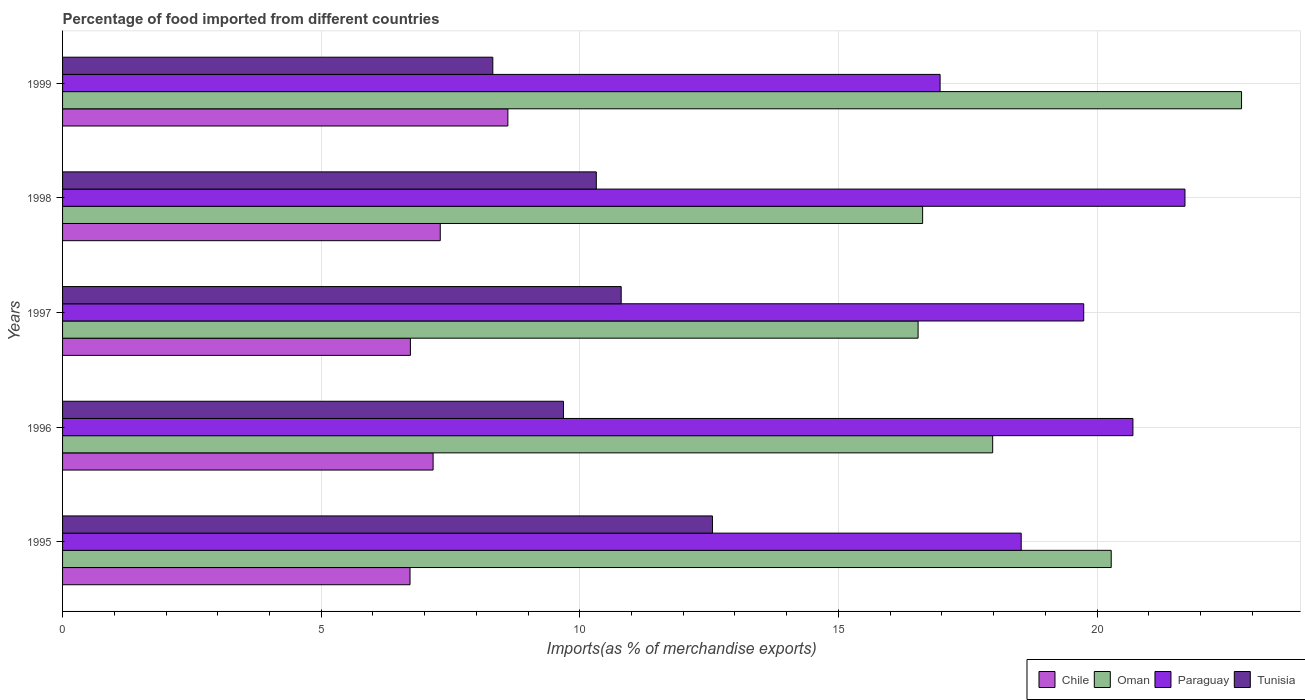How many different coloured bars are there?
Offer a terse response. 4. Are the number of bars on each tick of the Y-axis equal?
Give a very brief answer. Yes. How many bars are there on the 3rd tick from the top?
Keep it short and to the point. 4. What is the percentage of imports to different countries in Tunisia in 1996?
Keep it short and to the point. 9.68. Across all years, what is the maximum percentage of imports to different countries in Paraguay?
Your answer should be compact. 21.7. Across all years, what is the minimum percentage of imports to different countries in Paraguay?
Keep it short and to the point. 16.97. In which year was the percentage of imports to different countries in Chile maximum?
Make the answer very short. 1999. In which year was the percentage of imports to different countries in Paraguay minimum?
Your response must be concise. 1999. What is the total percentage of imports to different countries in Tunisia in the graph?
Provide a short and direct response. 51.69. What is the difference between the percentage of imports to different countries in Tunisia in 1995 and that in 1999?
Your answer should be compact. 4.25. What is the difference between the percentage of imports to different countries in Tunisia in 1996 and the percentage of imports to different countries in Chile in 1999?
Your answer should be very brief. 1.07. What is the average percentage of imports to different countries in Chile per year?
Provide a succinct answer. 7.3. In the year 1998, what is the difference between the percentage of imports to different countries in Chile and percentage of imports to different countries in Oman?
Offer a very short reply. -9.33. In how many years, is the percentage of imports to different countries in Oman greater than 21 %?
Provide a succinct answer. 1. What is the ratio of the percentage of imports to different countries in Oman in 1995 to that in 1999?
Your answer should be compact. 0.89. Is the percentage of imports to different countries in Oman in 1995 less than that in 1998?
Offer a terse response. No. What is the difference between the highest and the second highest percentage of imports to different countries in Oman?
Your answer should be compact. 2.52. What is the difference between the highest and the lowest percentage of imports to different countries in Paraguay?
Provide a short and direct response. 4.73. In how many years, is the percentage of imports to different countries in Paraguay greater than the average percentage of imports to different countries in Paraguay taken over all years?
Keep it short and to the point. 3. Is the sum of the percentage of imports to different countries in Tunisia in 1996 and 1998 greater than the maximum percentage of imports to different countries in Paraguay across all years?
Provide a succinct answer. No. What does the 4th bar from the top in 1999 represents?
Your response must be concise. Chile. What does the 3rd bar from the bottom in 1998 represents?
Your response must be concise. Paraguay. Is it the case that in every year, the sum of the percentage of imports to different countries in Paraguay and percentage of imports to different countries in Chile is greater than the percentage of imports to different countries in Oman?
Provide a short and direct response. Yes. How many years are there in the graph?
Keep it short and to the point. 5. What is the difference between two consecutive major ticks on the X-axis?
Ensure brevity in your answer.  5. Are the values on the major ticks of X-axis written in scientific E-notation?
Ensure brevity in your answer.  No. Does the graph contain grids?
Your answer should be compact. Yes. How many legend labels are there?
Give a very brief answer. 4. What is the title of the graph?
Your response must be concise. Percentage of food imported from different countries. Does "Belgium" appear as one of the legend labels in the graph?
Offer a very short reply. No. What is the label or title of the X-axis?
Your answer should be compact. Imports(as % of merchandise exports). What is the label or title of the Y-axis?
Ensure brevity in your answer.  Years. What is the Imports(as % of merchandise exports) of Chile in 1995?
Offer a very short reply. 6.72. What is the Imports(as % of merchandise exports) of Oman in 1995?
Your response must be concise. 20.27. What is the Imports(as % of merchandise exports) of Paraguay in 1995?
Ensure brevity in your answer.  18.53. What is the Imports(as % of merchandise exports) in Tunisia in 1995?
Your response must be concise. 12.57. What is the Imports(as % of merchandise exports) in Chile in 1996?
Make the answer very short. 7.16. What is the Imports(as % of merchandise exports) in Oman in 1996?
Give a very brief answer. 17.98. What is the Imports(as % of merchandise exports) of Paraguay in 1996?
Make the answer very short. 20.69. What is the Imports(as % of merchandise exports) in Tunisia in 1996?
Provide a short and direct response. 9.68. What is the Imports(as % of merchandise exports) in Chile in 1997?
Offer a very short reply. 6.73. What is the Imports(as % of merchandise exports) of Oman in 1997?
Your answer should be compact. 16.54. What is the Imports(as % of merchandise exports) in Paraguay in 1997?
Ensure brevity in your answer.  19.74. What is the Imports(as % of merchandise exports) of Tunisia in 1997?
Provide a short and direct response. 10.8. What is the Imports(as % of merchandise exports) in Chile in 1998?
Provide a succinct answer. 7.3. What is the Imports(as % of merchandise exports) in Oman in 1998?
Provide a succinct answer. 16.63. What is the Imports(as % of merchandise exports) in Paraguay in 1998?
Your response must be concise. 21.7. What is the Imports(as % of merchandise exports) in Tunisia in 1998?
Ensure brevity in your answer.  10.32. What is the Imports(as % of merchandise exports) of Chile in 1999?
Your answer should be very brief. 8.61. What is the Imports(as % of merchandise exports) of Oman in 1999?
Your answer should be very brief. 22.79. What is the Imports(as % of merchandise exports) of Paraguay in 1999?
Offer a terse response. 16.97. What is the Imports(as % of merchandise exports) in Tunisia in 1999?
Ensure brevity in your answer.  8.32. Across all years, what is the maximum Imports(as % of merchandise exports) in Chile?
Give a very brief answer. 8.61. Across all years, what is the maximum Imports(as % of merchandise exports) in Oman?
Offer a terse response. 22.79. Across all years, what is the maximum Imports(as % of merchandise exports) of Paraguay?
Offer a terse response. 21.7. Across all years, what is the maximum Imports(as % of merchandise exports) of Tunisia?
Your answer should be very brief. 12.57. Across all years, what is the minimum Imports(as % of merchandise exports) of Chile?
Provide a succinct answer. 6.72. Across all years, what is the minimum Imports(as % of merchandise exports) of Oman?
Ensure brevity in your answer.  16.54. Across all years, what is the minimum Imports(as % of merchandise exports) of Paraguay?
Ensure brevity in your answer.  16.97. Across all years, what is the minimum Imports(as % of merchandise exports) in Tunisia?
Ensure brevity in your answer.  8.32. What is the total Imports(as % of merchandise exports) in Chile in the graph?
Make the answer very short. 36.52. What is the total Imports(as % of merchandise exports) in Oman in the graph?
Provide a short and direct response. 94.22. What is the total Imports(as % of merchandise exports) in Paraguay in the graph?
Make the answer very short. 97.64. What is the total Imports(as % of merchandise exports) of Tunisia in the graph?
Provide a succinct answer. 51.69. What is the difference between the Imports(as % of merchandise exports) of Chile in 1995 and that in 1996?
Offer a terse response. -0.45. What is the difference between the Imports(as % of merchandise exports) of Oman in 1995 and that in 1996?
Provide a short and direct response. 2.29. What is the difference between the Imports(as % of merchandise exports) of Paraguay in 1995 and that in 1996?
Make the answer very short. -2.16. What is the difference between the Imports(as % of merchandise exports) of Tunisia in 1995 and that in 1996?
Offer a terse response. 2.88. What is the difference between the Imports(as % of merchandise exports) in Chile in 1995 and that in 1997?
Ensure brevity in your answer.  -0.01. What is the difference between the Imports(as % of merchandise exports) in Oman in 1995 and that in 1997?
Provide a succinct answer. 3.73. What is the difference between the Imports(as % of merchandise exports) in Paraguay in 1995 and that in 1997?
Offer a terse response. -1.21. What is the difference between the Imports(as % of merchandise exports) in Tunisia in 1995 and that in 1997?
Offer a terse response. 1.76. What is the difference between the Imports(as % of merchandise exports) of Chile in 1995 and that in 1998?
Provide a succinct answer. -0.58. What is the difference between the Imports(as % of merchandise exports) in Oman in 1995 and that in 1998?
Your answer should be very brief. 3.65. What is the difference between the Imports(as % of merchandise exports) in Paraguay in 1995 and that in 1998?
Your answer should be very brief. -3.17. What is the difference between the Imports(as % of merchandise exports) of Tunisia in 1995 and that in 1998?
Make the answer very short. 2.25. What is the difference between the Imports(as % of merchandise exports) of Chile in 1995 and that in 1999?
Keep it short and to the point. -1.89. What is the difference between the Imports(as % of merchandise exports) of Oman in 1995 and that in 1999?
Your answer should be compact. -2.52. What is the difference between the Imports(as % of merchandise exports) of Paraguay in 1995 and that in 1999?
Keep it short and to the point. 1.57. What is the difference between the Imports(as % of merchandise exports) of Tunisia in 1995 and that in 1999?
Your answer should be compact. 4.25. What is the difference between the Imports(as % of merchandise exports) in Chile in 1996 and that in 1997?
Give a very brief answer. 0.44. What is the difference between the Imports(as % of merchandise exports) of Oman in 1996 and that in 1997?
Make the answer very short. 1.44. What is the difference between the Imports(as % of merchandise exports) in Paraguay in 1996 and that in 1997?
Offer a terse response. 0.95. What is the difference between the Imports(as % of merchandise exports) in Tunisia in 1996 and that in 1997?
Give a very brief answer. -1.12. What is the difference between the Imports(as % of merchandise exports) of Chile in 1996 and that in 1998?
Your answer should be very brief. -0.14. What is the difference between the Imports(as % of merchandise exports) in Oman in 1996 and that in 1998?
Give a very brief answer. 1.35. What is the difference between the Imports(as % of merchandise exports) in Paraguay in 1996 and that in 1998?
Provide a short and direct response. -1.01. What is the difference between the Imports(as % of merchandise exports) in Tunisia in 1996 and that in 1998?
Offer a very short reply. -0.64. What is the difference between the Imports(as % of merchandise exports) of Chile in 1996 and that in 1999?
Offer a very short reply. -1.45. What is the difference between the Imports(as % of merchandise exports) of Oman in 1996 and that in 1999?
Your answer should be very brief. -4.81. What is the difference between the Imports(as % of merchandise exports) in Paraguay in 1996 and that in 1999?
Your answer should be compact. 3.73. What is the difference between the Imports(as % of merchandise exports) in Tunisia in 1996 and that in 1999?
Your response must be concise. 1.37. What is the difference between the Imports(as % of merchandise exports) of Chile in 1997 and that in 1998?
Ensure brevity in your answer.  -0.58. What is the difference between the Imports(as % of merchandise exports) in Oman in 1997 and that in 1998?
Your answer should be compact. -0.09. What is the difference between the Imports(as % of merchandise exports) of Paraguay in 1997 and that in 1998?
Offer a very short reply. -1.96. What is the difference between the Imports(as % of merchandise exports) in Tunisia in 1997 and that in 1998?
Ensure brevity in your answer.  0.48. What is the difference between the Imports(as % of merchandise exports) in Chile in 1997 and that in 1999?
Offer a terse response. -1.88. What is the difference between the Imports(as % of merchandise exports) in Oman in 1997 and that in 1999?
Your response must be concise. -6.25. What is the difference between the Imports(as % of merchandise exports) in Paraguay in 1997 and that in 1999?
Ensure brevity in your answer.  2.78. What is the difference between the Imports(as % of merchandise exports) of Tunisia in 1997 and that in 1999?
Ensure brevity in your answer.  2.48. What is the difference between the Imports(as % of merchandise exports) of Chile in 1998 and that in 1999?
Your answer should be very brief. -1.31. What is the difference between the Imports(as % of merchandise exports) of Oman in 1998 and that in 1999?
Your answer should be compact. -6.17. What is the difference between the Imports(as % of merchandise exports) in Paraguay in 1998 and that in 1999?
Keep it short and to the point. 4.73. What is the difference between the Imports(as % of merchandise exports) in Tunisia in 1998 and that in 1999?
Keep it short and to the point. 2. What is the difference between the Imports(as % of merchandise exports) of Chile in 1995 and the Imports(as % of merchandise exports) of Oman in 1996?
Offer a very short reply. -11.26. What is the difference between the Imports(as % of merchandise exports) of Chile in 1995 and the Imports(as % of merchandise exports) of Paraguay in 1996?
Offer a terse response. -13.98. What is the difference between the Imports(as % of merchandise exports) in Chile in 1995 and the Imports(as % of merchandise exports) in Tunisia in 1996?
Your response must be concise. -2.97. What is the difference between the Imports(as % of merchandise exports) in Oman in 1995 and the Imports(as % of merchandise exports) in Paraguay in 1996?
Your answer should be very brief. -0.42. What is the difference between the Imports(as % of merchandise exports) of Oman in 1995 and the Imports(as % of merchandise exports) of Tunisia in 1996?
Make the answer very short. 10.59. What is the difference between the Imports(as % of merchandise exports) in Paraguay in 1995 and the Imports(as % of merchandise exports) in Tunisia in 1996?
Give a very brief answer. 8.85. What is the difference between the Imports(as % of merchandise exports) of Chile in 1995 and the Imports(as % of merchandise exports) of Oman in 1997?
Make the answer very short. -9.82. What is the difference between the Imports(as % of merchandise exports) of Chile in 1995 and the Imports(as % of merchandise exports) of Paraguay in 1997?
Provide a succinct answer. -13.02. What is the difference between the Imports(as % of merchandise exports) in Chile in 1995 and the Imports(as % of merchandise exports) in Tunisia in 1997?
Your response must be concise. -4.08. What is the difference between the Imports(as % of merchandise exports) in Oman in 1995 and the Imports(as % of merchandise exports) in Paraguay in 1997?
Your answer should be very brief. 0.53. What is the difference between the Imports(as % of merchandise exports) of Oman in 1995 and the Imports(as % of merchandise exports) of Tunisia in 1997?
Your response must be concise. 9.47. What is the difference between the Imports(as % of merchandise exports) in Paraguay in 1995 and the Imports(as % of merchandise exports) in Tunisia in 1997?
Provide a short and direct response. 7.73. What is the difference between the Imports(as % of merchandise exports) of Chile in 1995 and the Imports(as % of merchandise exports) of Oman in 1998?
Ensure brevity in your answer.  -9.91. What is the difference between the Imports(as % of merchandise exports) of Chile in 1995 and the Imports(as % of merchandise exports) of Paraguay in 1998?
Make the answer very short. -14.98. What is the difference between the Imports(as % of merchandise exports) in Chile in 1995 and the Imports(as % of merchandise exports) in Tunisia in 1998?
Ensure brevity in your answer.  -3.6. What is the difference between the Imports(as % of merchandise exports) of Oman in 1995 and the Imports(as % of merchandise exports) of Paraguay in 1998?
Provide a succinct answer. -1.43. What is the difference between the Imports(as % of merchandise exports) in Oman in 1995 and the Imports(as % of merchandise exports) in Tunisia in 1998?
Give a very brief answer. 9.95. What is the difference between the Imports(as % of merchandise exports) of Paraguay in 1995 and the Imports(as % of merchandise exports) of Tunisia in 1998?
Provide a short and direct response. 8.21. What is the difference between the Imports(as % of merchandise exports) in Chile in 1995 and the Imports(as % of merchandise exports) in Oman in 1999?
Offer a very short reply. -16.08. What is the difference between the Imports(as % of merchandise exports) of Chile in 1995 and the Imports(as % of merchandise exports) of Paraguay in 1999?
Give a very brief answer. -10.25. What is the difference between the Imports(as % of merchandise exports) of Chile in 1995 and the Imports(as % of merchandise exports) of Tunisia in 1999?
Offer a very short reply. -1.6. What is the difference between the Imports(as % of merchandise exports) of Oman in 1995 and the Imports(as % of merchandise exports) of Paraguay in 1999?
Provide a short and direct response. 3.31. What is the difference between the Imports(as % of merchandise exports) of Oman in 1995 and the Imports(as % of merchandise exports) of Tunisia in 1999?
Your answer should be compact. 11.96. What is the difference between the Imports(as % of merchandise exports) in Paraguay in 1995 and the Imports(as % of merchandise exports) in Tunisia in 1999?
Offer a terse response. 10.22. What is the difference between the Imports(as % of merchandise exports) in Chile in 1996 and the Imports(as % of merchandise exports) in Oman in 1997?
Offer a very short reply. -9.38. What is the difference between the Imports(as % of merchandise exports) in Chile in 1996 and the Imports(as % of merchandise exports) in Paraguay in 1997?
Provide a succinct answer. -12.58. What is the difference between the Imports(as % of merchandise exports) in Chile in 1996 and the Imports(as % of merchandise exports) in Tunisia in 1997?
Your answer should be very brief. -3.64. What is the difference between the Imports(as % of merchandise exports) of Oman in 1996 and the Imports(as % of merchandise exports) of Paraguay in 1997?
Provide a succinct answer. -1.76. What is the difference between the Imports(as % of merchandise exports) in Oman in 1996 and the Imports(as % of merchandise exports) in Tunisia in 1997?
Your answer should be very brief. 7.18. What is the difference between the Imports(as % of merchandise exports) in Paraguay in 1996 and the Imports(as % of merchandise exports) in Tunisia in 1997?
Provide a short and direct response. 9.89. What is the difference between the Imports(as % of merchandise exports) in Chile in 1996 and the Imports(as % of merchandise exports) in Oman in 1998?
Provide a succinct answer. -9.46. What is the difference between the Imports(as % of merchandise exports) of Chile in 1996 and the Imports(as % of merchandise exports) of Paraguay in 1998?
Ensure brevity in your answer.  -14.54. What is the difference between the Imports(as % of merchandise exports) in Chile in 1996 and the Imports(as % of merchandise exports) in Tunisia in 1998?
Give a very brief answer. -3.16. What is the difference between the Imports(as % of merchandise exports) of Oman in 1996 and the Imports(as % of merchandise exports) of Paraguay in 1998?
Provide a short and direct response. -3.72. What is the difference between the Imports(as % of merchandise exports) in Oman in 1996 and the Imports(as % of merchandise exports) in Tunisia in 1998?
Keep it short and to the point. 7.66. What is the difference between the Imports(as % of merchandise exports) in Paraguay in 1996 and the Imports(as % of merchandise exports) in Tunisia in 1998?
Your answer should be compact. 10.37. What is the difference between the Imports(as % of merchandise exports) of Chile in 1996 and the Imports(as % of merchandise exports) of Oman in 1999?
Give a very brief answer. -15.63. What is the difference between the Imports(as % of merchandise exports) in Chile in 1996 and the Imports(as % of merchandise exports) in Paraguay in 1999?
Make the answer very short. -9.8. What is the difference between the Imports(as % of merchandise exports) of Chile in 1996 and the Imports(as % of merchandise exports) of Tunisia in 1999?
Provide a succinct answer. -1.15. What is the difference between the Imports(as % of merchandise exports) of Oman in 1996 and the Imports(as % of merchandise exports) of Paraguay in 1999?
Provide a short and direct response. 1.02. What is the difference between the Imports(as % of merchandise exports) in Oman in 1996 and the Imports(as % of merchandise exports) in Tunisia in 1999?
Your response must be concise. 9.66. What is the difference between the Imports(as % of merchandise exports) of Paraguay in 1996 and the Imports(as % of merchandise exports) of Tunisia in 1999?
Keep it short and to the point. 12.38. What is the difference between the Imports(as % of merchandise exports) in Chile in 1997 and the Imports(as % of merchandise exports) in Oman in 1998?
Your answer should be compact. -9.9. What is the difference between the Imports(as % of merchandise exports) in Chile in 1997 and the Imports(as % of merchandise exports) in Paraguay in 1998?
Your answer should be compact. -14.98. What is the difference between the Imports(as % of merchandise exports) in Chile in 1997 and the Imports(as % of merchandise exports) in Tunisia in 1998?
Provide a succinct answer. -3.59. What is the difference between the Imports(as % of merchandise exports) of Oman in 1997 and the Imports(as % of merchandise exports) of Paraguay in 1998?
Give a very brief answer. -5.16. What is the difference between the Imports(as % of merchandise exports) in Oman in 1997 and the Imports(as % of merchandise exports) in Tunisia in 1998?
Ensure brevity in your answer.  6.22. What is the difference between the Imports(as % of merchandise exports) of Paraguay in 1997 and the Imports(as % of merchandise exports) of Tunisia in 1998?
Your response must be concise. 9.42. What is the difference between the Imports(as % of merchandise exports) of Chile in 1997 and the Imports(as % of merchandise exports) of Oman in 1999?
Your answer should be compact. -16.07. What is the difference between the Imports(as % of merchandise exports) in Chile in 1997 and the Imports(as % of merchandise exports) in Paraguay in 1999?
Give a very brief answer. -10.24. What is the difference between the Imports(as % of merchandise exports) of Chile in 1997 and the Imports(as % of merchandise exports) of Tunisia in 1999?
Make the answer very short. -1.59. What is the difference between the Imports(as % of merchandise exports) in Oman in 1997 and the Imports(as % of merchandise exports) in Paraguay in 1999?
Offer a terse response. -0.43. What is the difference between the Imports(as % of merchandise exports) in Oman in 1997 and the Imports(as % of merchandise exports) in Tunisia in 1999?
Make the answer very short. 8.22. What is the difference between the Imports(as % of merchandise exports) in Paraguay in 1997 and the Imports(as % of merchandise exports) in Tunisia in 1999?
Your answer should be compact. 11.42. What is the difference between the Imports(as % of merchandise exports) in Chile in 1998 and the Imports(as % of merchandise exports) in Oman in 1999?
Your response must be concise. -15.49. What is the difference between the Imports(as % of merchandise exports) of Chile in 1998 and the Imports(as % of merchandise exports) of Paraguay in 1999?
Offer a terse response. -9.66. What is the difference between the Imports(as % of merchandise exports) in Chile in 1998 and the Imports(as % of merchandise exports) in Tunisia in 1999?
Provide a succinct answer. -1.02. What is the difference between the Imports(as % of merchandise exports) in Oman in 1998 and the Imports(as % of merchandise exports) in Paraguay in 1999?
Keep it short and to the point. -0.34. What is the difference between the Imports(as % of merchandise exports) of Oman in 1998 and the Imports(as % of merchandise exports) of Tunisia in 1999?
Make the answer very short. 8.31. What is the difference between the Imports(as % of merchandise exports) of Paraguay in 1998 and the Imports(as % of merchandise exports) of Tunisia in 1999?
Your answer should be compact. 13.38. What is the average Imports(as % of merchandise exports) in Chile per year?
Your answer should be very brief. 7.3. What is the average Imports(as % of merchandise exports) of Oman per year?
Provide a short and direct response. 18.84. What is the average Imports(as % of merchandise exports) in Paraguay per year?
Provide a succinct answer. 19.53. What is the average Imports(as % of merchandise exports) of Tunisia per year?
Offer a terse response. 10.34. In the year 1995, what is the difference between the Imports(as % of merchandise exports) of Chile and Imports(as % of merchandise exports) of Oman?
Provide a short and direct response. -13.56. In the year 1995, what is the difference between the Imports(as % of merchandise exports) of Chile and Imports(as % of merchandise exports) of Paraguay?
Offer a very short reply. -11.82. In the year 1995, what is the difference between the Imports(as % of merchandise exports) of Chile and Imports(as % of merchandise exports) of Tunisia?
Provide a short and direct response. -5.85. In the year 1995, what is the difference between the Imports(as % of merchandise exports) in Oman and Imports(as % of merchandise exports) in Paraguay?
Keep it short and to the point. 1.74. In the year 1995, what is the difference between the Imports(as % of merchandise exports) of Oman and Imports(as % of merchandise exports) of Tunisia?
Provide a short and direct response. 7.71. In the year 1995, what is the difference between the Imports(as % of merchandise exports) in Paraguay and Imports(as % of merchandise exports) in Tunisia?
Provide a short and direct response. 5.97. In the year 1996, what is the difference between the Imports(as % of merchandise exports) in Chile and Imports(as % of merchandise exports) in Oman?
Your response must be concise. -10.82. In the year 1996, what is the difference between the Imports(as % of merchandise exports) in Chile and Imports(as % of merchandise exports) in Paraguay?
Your answer should be very brief. -13.53. In the year 1996, what is the difference between the Imports(as % of merchandise exports) of Chile and Imports(as % of merchandise exports) of Tunisia?
Provide a short and direct response. -2.52. In the year 1996, what is the difference between the Imports(as % of merchandise exports) in Oman and Imports(as % of merchandise exports) in Paraguay?
Your answer should be compact. -2.71. In the year 1996, what is the difference between the Imports(as % of merchandise exports) of Oman and Imports(as % of merchandise exports) of Tunisia?
Your answer should be compact. 8.3. In the year 1996, what is the difference between the Imports(as % of merchandise exports) in Paraguay and Imports(as % of merchandise exports) in Tunisia?
Provide a short and direct response. 11.01. In the year 1997, what is the difference between the Imports(as % of merchandise exports) of Chile and Imports(as % of merchandise exports) of Oman?
Keep it short and to the point. -9.82. In the year 1997, what is the difference between the Imports(as % of merchandise exports) in Chile and Imports(as % of merchandise exports) in Paraguay?
Offer a very short reply. -13.02. In the year 1997, what is the difference between the Imports(as % of merchandise exports) in Chile and Imports(as % of merchandise exports) in Tunisia?
Your answer should be very brief. -4.08. In the year 1997, what is the difference between the Imports(as % of merchandise exports) in Oman and Imports(as % of merchandise exports) in Paraguay?
Your response must be concise. -3.2. In the year 1997, what is the difference between the Imports(as % of merchandise exports) of Oman and Imports(as % of merchandise exports) of Tunisia?
Keep it short and to the point. 5.74. In the year 1997, what is the difference between the Imports(as % of merchandise exports) in Paraguay and Imports(as % of merchandise exports) in Tunisia?
Your answer should be very brief. 8.94. In the year 1998, what is the difference between the Imports(as % of merchandise exports) in Chile and Imports(as % of merchandise exports) in Oman?
Keep it short and to the point. -9.33. In the year 1998, what is the difference between the Imports(as % of merchandise exports) of Chile and Imports(as % of merchandise exports) of Paraguay?
Provide a short and direct response. -14.4. In the year 1998, what is the difference between the Imports(as % of merchandise exports) in Chile and Imports(as % of merchandise exports) in Tunisia?
Your answer should be compact. -3.02. In the year 1998, what is the difference between the Imports(as % of merchandise exports) of Oman and Imports(as % of merchandise exports) of Paraguay?
Provide a short and direct response. -5.07. In the year 1998, what is the difference between the Imports(as % of merchandise exports) of Oman and Imports(as % of merchandise exports) of Tunisia?
Ensure brevity in your answer.  6.31. In the year 1998, what is the difference between the Imports(as % of merchandise exports) of Paraguay and Imports(as % of merchandise exports) of Tunisia?
Keep it short and to the point. 11.38. In the year 1999, what is the difference between the Imports(as % of merchandise exports) of Chile and Imports(as % of merchandise exports) of Oman?
Ensure brevity in your answer.  -14.18. In the year 1999, what is the difference between the Imports(as % of merchandise exports) in Chile and Imports(as % of merchandise exports) in Paraguay?
Keep it short and to the point. -8.36. In the year 1999, what is the difference between the Imports(as % of merchandise exports) in Chile and Imports(as % of merchandise exports) in Tunisia?
Your answer should be very brief. 0.29. In the year 1999, what is the difference between the Imports(as % of merchandise exports) of Oman and Imports(as % of merchandise exports) of Paraguay?
Keep it short and to the point. 5.83. In the year 1999, what is the difference between the Imports(as % of merchandise exports) in Oman and Imports(as % of merchandise exports) in Tunisia?
Ensure brevity in your answer.  14.48. In the year 1999, what is the difference between the Imports(as % of merchandise exports) in Paraguay and Imports(as % of merchandise exports) in Tunisia?
Offer a terse response. 8.65. What is the ratio of the Imports(as % of merchandise exports) in Chile in 1995 to that in 1996?
Your answer should be compact. 0.94. What is the ratio of the Imports(as % of merchandise exports) in Oman in 1995 to that in 1996?
Your answer should be very brief. 1.13. What is the ratio of the Imports(as % of merchandise exports) of Paraguay in 1995 to that in 1996?
Your response must be concise. 0.9. What is the ratio of the Imports(as % of merchandise exports) of Tunisia in 1995 to that in 1996?
Your response must be concise. 1.3. What is the ratio of the Imports(as % of merchandise exports) in Oman in 1995 to that in 1997?
Give a very brief answer. 1.23. What is the ratio of the Imports(as % of merchandise exports) in Paraguay in 1995 to that in 1997?
Give a very brief answer. 0.94. What is the ratio of the Imports(as % of merchandise exports) of Tunisia in 1995 to that in 1997?
Your answer should be compact. 1.16. What is the ratio of the Imports(as % of merchandise exports) in Oman in 1995 to that in 1998?
Provide a succinct answer. 1.22. What is the ratio of the Imports(as % of merchandise exports) in Paraguay in 1995 to that in 1998?
Provide a short and direct response. 0.85. What is the ratio of the Imports(as % of merchandise exports) in Tunisia in 1995 to that in 1998?
Your answer should be compact. 1.22. What is the ratio of the Imports(as % of merchandise exports) in Chile in 1995 to that in 1999?
Provide a succinct answer. 0.78. What is the ratio of the Imports(as % of merchandise exports) in Oman in 1995 to that in 1999?
Give a very brief answer. 0.89. What is the ratio of the Imports(as % of merchandise exports) in Paraguay in 1995 to that in 1999?
Provide a succinct answer. 1.09. What is the ratio of the Imports(as % of merchandise exports) of Tunisia in 1995 to that in 1999?
Your answer should be compact. 1.51. What is the ratio of the Imports(as % of merchandise exports) in Chile in 1996 to that in 1997?
Your answer should be very brief. 1.07. What is the ratio of the Imports(as % of merchandise exports) in Oman in 1996 to that in 1997?
Your answer should be very brief. 1.09. What is the ratio of the Imports(as % of merchandise exports) in Paraguay in 1996 to that in 1997?
Ensure brevity in your answer.  1.05. What is the ratio of the Imports(as % of merchandise exports) of Tunisia in 1996 to that in 1997?
Your response must be concise. 0.9. What is the ratio of the Imports(as % of merchandise exports) of Chile in 1996 to that in 1998?
Give a very brief answer. 0.98. What is the ratio of the Imports(as % of merchandise exports) in Oman in 1996 to that in 1998?
Make the answer very short. 1.08. What is the ratio of the Imports(as % of merchandise exports) of Paraguay in 1996 to that in 1998?
Offer a very short reply. 0.95. What is the ratio of the Imports(as % of merchandise exports) in Tunisia in 1996 to that in 1998?
Your response must be concise. 0.94. What is the ratio of the Imports(as % of merchandise exports) in Chile in 1996 to that in 1999?
Ensure brevity in your answer.  0.83. What is the ratio of the Imports(as % of merchandise exports) in Oman in 1996 to that in 1999?
Offer a very short reply. 0.79. What is the ratio of the Imports(as % of merchandise exports) in Paraguay in 1996 to that in 1999?
Offer a very short reply. 1.22. What is the ratio of the Imports(as % of merchandise exports) in Tunisia in 1996 to that in 1999?
Offer a terse response. 1.16. What is the ratio of the Imports(as % of merchandise exports) in Chile in 1997 to that in 1998?
Your answer should be very brief. 0.92. What is the ratio of the Imports(as % of merchandise exports) in Oman in 1997 to that in 1998?
Keep it short and to the point. 0.99. What is the ratio of the Imports(as % of merchandise exports) of Paraguay in 1997 to that in 1998?
Give a very brief answer. 0.91. What is the ratio of the Imports(as % of merchandise exports) in Tunisia in 1997 to that in 1998?
Keep it short and to the point. 1.05. What is the ratio of the Imports(as % of merchandise exports) in Chile in 1997 to that in 1999?
Offer a terse response. 0.78. What is the ratio of the Imports(as % of merchandise exports) of Oman in 1997 to that in 1999?
Ensure brevity in your answer.  0.73. What is the ratio of the Imports(as % of merchandise exports) in Paraguay in 1997 to that in 1999?
Your answer should be compact. 1.16. What is the ratio of the Imports(as % of merchandise exports) of Tunisia in 1997 to that in 1999?
Your answer should be compact. 1.3. What is the ratio of the Imports(as % of merchandise exports) in Chile in 1998 to that in 1999?
Your response must be concise. 0.85. What is the ratio of the Imports(as % of merchandise exports) in Oman in 1998 to that in 1999?
Offer a terse response. 0.73. What is the ratio of the Imports(as % of merchandise exports) of Paraguay in 1998 to that in 1999?
Keep it short and to the point. 1.28. What is the ratio of the Imports(as % of merchandise exports) of Tunisia in 1998 to that in 1999?
Give a very brief answer. 1.24. What is the difference between the highest and the second highest Imports(as % of merchandise exports) of Chile?
Provide a succinct answer. 1.31. What is the difference between the highest and the second highest Imports(as % of merchandise exports) in Oman?
Ensure brevity in your answer.  2.52. What is the difference between the highest and the second highest Imports(as % of merchandise exports) of Tunisia?
Your answer should be compact. 1.76. What is the difference between the highest and the lowest Imports(as % of merchandise exports) of Chile?
Make the answer very short. 1.89. What is the difference between the highest and the lowest Imports(as % of merchandise exports) of Oman?
Give a very brief answer. 6.25. What is the difference between the highest and the lowest Imports(as % of merchandise exports) in Paraguay?
Your answer should be compact. 4.73. What is the difference between the highest and the lowest Imports(as % of merchandise exports) of Tunisia?
Make the answer very short. 4.25. 